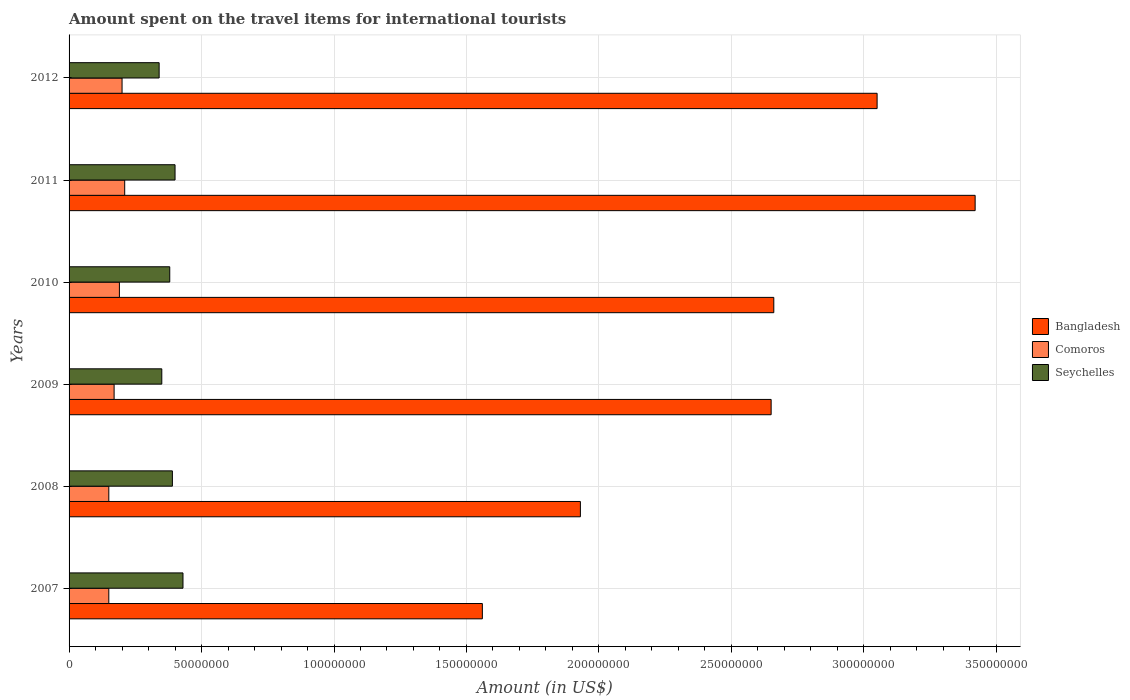How many groups of bars are there?
Make the answer very short. 6. Are the number of bars on each tick of the Y-axis equal?
Make the answer very short. Yes. What is the label of the 3rd group of bars from the top?
Your answer should be compact. 2010. What is the amount spent on the travel items for international tourists in Bangladesh in 2007?
Keep it short and to the point. 1.56e+08. Across all years, what is the maximum amount spent on the travel items for international tourists in Seychelles?
Provide a succinct answer. 4.30e+07. Across all years, what is the minimum amount spent on the travel items for international tourists in Comoros?
Make the answer very short. 1.50e+07. In which year was the amount spent on the travel items for international tourists in Comoros maximum?
Make the answer very short. 2011. What is the total amount spent on the travel items for international tourists in Comoros in the graph?
Make the answer very short. 1.07e+08. What is the difference between the amount spent on the travel items for international tourists in Bangladesh in 2008 and that in 2009?
Offer a very short reply. -7.20e+07. What is the difference between the amount spent on the travel items for international tourists in Bangladesh in 2009 and the amount spent on the travel items for international tourists in Seychelles in 2011?
Your answer should be compact. 2.25e+08. What is the average amount spent on the travel items for international tourists in Seychelles per year?
Ensure brevity in your answer.  3.82e+07. In the year 2012, what is the difference between the amount spent on the travel items for international tourists in Seychelles and amount spent on the travel items for international tourists in Bangladesh?
Your response must be concise. -2.71e+08. In how many years, is the amount spent on the travel items for international tourists in Bangladesh greater than 290000000 US$?
Provide a succinct answer. 2. Is the amount spent on the travel items for international tourists in Seychelles in 2010 less than that in 2012?
Your answer should be very brief. No. Is the difference between the amount spent on the travel items for international tourists in Seychelles in 2010 and 2011 greater than the difference between the amount spent on the travel items for international tourists in Bangladesh in 2010 and 2011?
Keep it short and to the point. Yes. What is the difference between the highest and the second highest amount spent on the travel items for international tourists in Comoros?
Make the answer very short. 1.00e+06. In how many years, is the amount spent on the travel items for international tourists in Comoros greater than the average amount spent on the travel items for international tourists in Comoros taken over all years?
Your response must be concise. 3. What does the 2nd bar from the top in 2012 represents?
Your answer should be compact. Comoros. What does the 1st bar from the bottom in 2009 represents?
Ensure brevity in your answer.  Bangladesh. Is it the case that in every year, the sum of the amount spent on the travel items for international tourists in Seychelles and amount spent on the travel items for international tourists in Comoros is greater than the amount spent on the travel items for international tourists in Bangladesh?
Offer a very short reply. No. How many bars are there?
Give a very brief answer. 18. Are all the bars in the graph horizontal?
Provide a succinct answer. Yes. What is the difference between two consecutive major ticks on the X-axis?
Your answer should be very brief. 5.00e+07. Where does the legend appear in the graph?
Your answer should be compact. Center right. How are the legend labels stacked?
Make the answer very short. Vertical. What is the title of the graph?
Your answer should be very brief. Amount spent on the travel items for international tourists. Does "San Marino" appear as one of the legend labels in the graph?
Your response must be concise. No. What is the Amount (in US$) of Bangladesh in 2007?
Ensure brevity in your answer.  1.56e+08. What is the Amount (in US$) in Comoros in 2007?
Offer a very short reply. 1.50e+07. What is the Amount (in US$) of Seychelles in 2007?
Your answer should be compact. 4.30e+07. What is the Amount (in US$) of Bangladesh in 2008?
Offer a terse response. 1.93e+08. What is the Amount (in US$) of Comoros in 2008?
Your answer should be very brief. 1.50e+07. What is the Amount (in US$) of Seychelles in 2008?
Keep it short and to the point. 3.90e+07. What is the Amount (in US$) in Bangladesh in 2009?
Your answer should be very brief. 2.65e+08. What is the Amount (in US$) in Comoros in 2009?
Offer a very short reply. 1.70e+07. What is the Amount (in US$) in Seychelles in 2009?
Keep it short and to the point. 3.50e+07. What is the Amount (in US$) in Bangladesh in 2010?
Keep it short and to the point. 2.66e+08. What is the Amount (in US$) of Comoros in 2010?
Provide a succinct answer. 1.90e+07. What is the Amount (in US$) in Seychelles in 2010?
Your answer should be compact. 3.80e+07. What is the Amount (in US$) in Bangladesh in 2011?
Your answer should be compact. 3.42e+08. What is the Amount (in US$) in Comoros in 2011?
Provide a short and direct response. 2.10e+07. What is the Amount (in US$) of Seychelles in 2011?
Your answer should be compact. 4.00e+07. What is the Amount (in US$) in Bangladesh in 2012?
Ensure brevity in your answer.  3.05e+08. What is the Amount (in US$) of Comoros in 2012?
Offer a very short reply. 2.00e+07. What is the Amount (in US$) of Seychelles in 2012?
Make the answer very short. 3.40e+07. Across all years, what is the maximum Amount (in US$) of Bangladesh?
Give a very brief answer. 3.42e+08. Across all years, what is the maximum Amount (in US$) in Comoros?
Provide a succinct answer. 2.10e+07. Across all years, what is the maximum Amount (in US$) of Seychelles?
Offer a terse response. 4.30e+07. Across all years, what is the minimum Amount (in US$) of Bangladesh?
Provide a succinct answer. 1.56e+08. Across all years, what is the minimum Amount (in US$) of Comoros?
Your response must be concise. 1.50e+07. Across all years, what is the minimum Amount (in US$) in Seychelles?
Ensure brevity in your answer.  3.40e+07. What is the total Amount (in US$) of Bangladesh in the graph?
Provide a succinct answer. 1.53e+09. What is the total Amount (in US$) in Comoros in the graph?
Keep it short and to the point. 1.07e+08. What is the total Amount (in US$) of Seychelles in the graph?
Give a very brief answer. 2.29e+08. What is the difference between the Amount (in US$) of Bangladesh in 2007 and that in 2008?
Your answer should be very brief. -3.70e+07. What is the difference between the Amount (in US$) of Comoros in 2007 and that in 2008?
Ensure brevity in your answer.  0. What is the difference between the Amount (in US$) of Seychelles in 2007 and that in 2008?
Ensure brevity in your answer.  4.00e+06. What is the difference between the Amount (in US$) in Bangladesh in 2007 and that in 2009?
Keep it short and to the point. -1.09e+08. What is the difference between the Amount (in US$) in Bangladesh in 2007 and that in 2010?
Your answer should be compact. -1.10e+08. What is the difference between the Amount (in US$) in Seychelles in 2007 and that in 2010?
Keep it short and to the point. 5.00e+06. What is the difference between the Amount (in US$) in Bangladesh in 2007 and that in 2011?
Provide a short and direct response. -1.86e+08. What is the difference between the Amount (in US$) of Comoros in 2007 and that in 2011?
Keep it short and to the point. -6.00e+06. What is the difference between the Amount (in US$) of Seychelles in 2007 and that in 2011?
Offer a very short reply. 3.00e+06. What is the difference between the Amount (in US$) in Bangladesh in 2007 and that in 2012?
Keep it short and to the point. -1.49e+08. What is the difference between the Amount (in US$) of Comoros in 2007 and that in 2012?
Provide a short and direct response. -5.00e+06. What is the difference between the Amount (in US$) of Seychelles in 2007 and that in 2012?
Keep it short and to the point. 9.00e+06. What is the difference between the Amount (in US$) in Bangladesh in 2008 and that in 2009?
Give a very brief answer. -7.20e+07. What is the difference between the Amount (in US$) of Comoros in 2008 and that in 2009?
Provide a succinct answer. -2.00e+06. What is the difference between the Amount (in US$) in Bangladesh in 2008 and that in 2010?
Offer a very short reply. -7.30e+07. What is the difference between the Amount (in US$) in Comoros in 2008 and that in 2010?
Keep it short and to the point. -4.00e+06. What is the difference between the Amount (in US$) in Seychelles in 2008 and that in 2010?
Provide a succinct answer. 1.00e+06. What is the difference between the Amount (in US$) of Bangladesh in 2008 and that in 2011?
Offer a very short reply. -1.49e+08. What is the difference between the Amount (in US$) in Comoros in 2008 and that in 2011?
Offer a very short reply. -6.00e+06. What is the difference between the Amount (in US$) in Seychelles in 2008 and that in 2011?
Make the answer very short. -1.00e+06. What is the difference between the Amount (in US$) of Bangladesh in 2008 and that in 2012?
Ensure brevity in your answer.  -1.12e+08. What is the difference between the Amount (in US$) of Comoros in 2008 and that in 2012?
Your response must be concise. -5.00e+06. What is the difference between the Amount (in US$) of Comoros in 2009 and that in 2010?
Give a very brief answer. -2.00e+06. What is the difference between the Amount (in US$) in Bangladesh in 2009 and that in 2011?
Give a very brief answer. -7.70e+07. What is the difference between the Amount (in US$) of Seychelles in 2009 and that in 2011?
Provide a succinct answer. -5.00e+06. What is the difference between the Amount (in US$) of Bangladesh in 2009 and that in 2012?
Make the answer very short. -4.00e+07. What is the difference between the Amount (in US$) in Bangladesh in 2010 and that in 2011?
Make the answer very short. -7.60e+07. What is the difference between the Amount (in US$) of Seychelles in 2010 and that in 2011?
Ensure brevity in your answer.  -2.00e+06. What is the difference between the Amount (in US$) in Bangladesh in 2010 and that in 2012?
Your answer should be compact. -3.90e+07. What is the difference between the Amount (in US$) of Comoros in 2010 and that in 2012?
Your answer should be very brief. -1.00e+06. What is the difference between the Amount (in US$) of Bangladesh in 2011 and that in 2012?
Provide a succinct answer. 3.70e+07. What is the difference between the Amount (in US$) in Comoros in 2011 and that in 2012?
Your answer should be very brief. 1.00e+06. What is the difference between the Amount (in US$) in Seychelles in 2011 and that in 2012?
Your response must be concise. 6.00e+06. What is the difference between the Amount (in US$) of Bangladesh in 2007 and the Amount (in US$) of Comoros in 2008?
Your response must be concise. 1.41e+08. What is the difference between the Amount (in US$) in Bangladesh in 2007 and the Amount (in US$) in Seychelles in 2008?
Ensure brevity in your answer.  1.17e+08. What is the difference between the Amount (in US$) of Comoros in 2007 and the Amount (in US$) of Seychelles in 2008?
Offer a terse response. -2.40e+07. What is the difference between the Amount (in US$) in Bangladesh in 2007 and the Amount (in US$) in Comoros in 2009?
Your response must be concise. 1.39e+08. What is the difference between the Amount (in US$) in Bangladesh in 2007 and the Amount (in US$) in Seychelles in 2009?
Your answer should be compact. 1.21e+08. What is the difference between the Amount (in US$) in Comoros in 2007 and the Amount (in US$) in Seychelles in 2009?
Your answer should be very brief. -2.00e+07. What is the difference between the Amount (in US$) in Bangladesh in 2007 and the Amount (in US$) in Comoros in 2010?
Offer a very short reply. 1.37e+08. What is the difference between the Amount (in US$) in Bangladesh in 2007 and the Amount (in US$) in Seychelles in 2010?
Your answer should be very brief. 1.18e+08. What is the difference between the Amount (in US$) in Comoros in 2007 and the Amount (in US$) in Seychelles in 2010?
Provide a succinct answer. -2.30e+07. What is the difference between the Amount (in US$) of Bangladesh in 2007 and the Amount (in US$) of Comoros in 2011?
Provide a short and direct response. 1.35e+08. What is the difference between the Amount (in US$) of Bangladesh in 2007 and the Amount (in US$) of Seychelles in 2011?
Offer a very short reply. 1.16e+08. What is the difference between the Amount (in US$) in Comoros in 2007 and the Amount (in US$) in Seychelles in 2011?
Give a very brief answer. -2.50e+07. What is the difference between the Amount (in US$) of Bangladesh in 2007 and the Amount (in US$) of Comoros in 2012?
Keep it short and to the point. 1.36e+08. What is the difference between the Amount (in US$) in Bangladesh in 2007 and the Amount (in US$) in Seychelles in 2012?
Your answer should be very brief. 1.22e+08. What is the difference between the Amount (in US$) in Comoros in 2007 and the Amount (in US$) in Seychelles in 2012?
Give a very brief answer. -1.90e+07. What is the difference between the Amount (in US$) of Bangladesh in 2008 and the Amount (in US$) of Comoros in 2009?
Your response must be concise. 1.76e+08. What is the difference between the Amount (in US$) of Bangladesh in 2008 and the Amount (in US$) of Seychelles in 2009?
Offer a very short reply. 1.58e+08. What is the difference between the Amount (in US$) in Comoros in 2008 and the Amount (in US$) in Seychelles in 2009?
Ensure brevity in your answer.  -2.00e+07. What is the difference between the Amount (in US$) in Bangladesh in 2008 and the Amount (in US$) in Comoros in 2010?
Your response must be concise. 1.74e+08. What is the difference between the Amount (in US$) in Bangladesh in 2008 and the Amount (in US$) in Seychelles in 2010?
Offer a terse response. 1.55e+08. What is the difference between the Amount (in US$) in Comoros in 2008 and the Amount (in US$) in Seychelles in 2010?
Your answer should be compact. -2.30e+07. What is the difference between the Amount (in US$) of Bangladesh in 2008 and the Amount (in US$) of Comoros in 2011?
Provide a short and direct response. 1.72e+08. What is the difference between the Amount (in US$) in Bangladesh in 2008 and the Amount (in US$) in Seychelles in 2011?
Your response must be concise. 1.53e+08. What is the difference between the Amount (in US$) of Comoros in 2008 and the Amount (in US$) of Seychelles in 2011?
Provide a succinct answer. -2.50e+07. What is the difference between the Amount (in US$) of Bangladesh in 2008 and the Amount (in US$) of Comoros in 2012?
Keep it short and to the point. 1.73e+08. What is the difference between the Amount (in US$) of Bangladesh in 2008 and the Amount (in US$) of Seychelles in 2012?
Your answer should be compact. 1.59e+08. What is the difference between the Amount (in US$) in Comoros in 2008 and the Amount (in US$) in Seychelles in 2012?
Offer a very short reply. -1.90e+07. What is the difference between the Amount (in US$) in Bangladesh in 2009 and the Amount (in US$) in Comoros in 2010?
Offer a very short reply. 2.46e+08. What is the difference between the Amount (in US$) in Bangladesh in 2009 and the Amount (in US$) in Seychelles in 2010?
Make the answer very short. 2.27e+08. What is the difference between the Amount (in US$) in Comoros in 2009 and the Amount (in US$) in Seychelles in 2010?
Ensure brevity in your answer.  -2.10e+07. What is the difference between the Amount (in US$) of Bangladesh in 2009 and the Amount (in US$) of Comoros in 2011?
Your answer should be very brief. 2.44e+08. What is the difference between the Amount (in US$) of Bangladesh in 2009 and the Amount (in US$) of Seychelles in 2011?
Your response must be concise. 2.25e+08. What is the difference between the Amount (in US$) of Comoros in 2009 and the Amount (in US$) of Seychelles in 2011?
Offer a terse response. -2.30e+07. What is the difference between the Amount (in US$) in Bangladesh in 2009 and the Amount (in US$) in Comoros in 2012?
Offer a terse response. 2.45e+08. What is the difference between the Amount (in US$) of Bangladesh in 2009 and the Amount (in US$) of Seychelles in 2012?
Offer a very short reply. 2.31e+08. What is the difference between the Amount (in US$) in Comoros in 2009 and the Amount (in US$) in Seychelles in 2012?
Provide a short and direct response. -1.70e+07. What is the difference between the Amount (in US$) of Bangladesh in 2010 and the Amount (in US$) of Comoros in 2011?
Your answer should be compact. 2.45e+08. What is the difference between the Amount (in US$) of Bangladesh in 2010 and the Amount (in US$) of Seychelles in 2011?
Your response must be concise. 2.26e+08. What is the difference between the Amount (in US$) of Comoros in 2010 and the Amount (in US$) of Seychelles in 2011?
Make the answer very short. -2.10e+07. What is the difference between the Amount (in US$) in Bangladesh in 2010 and the Amount (in US$) in Comoros in 2012?
Provide a succinct answer. 2.46e+08. What is the difference between the Amount (in US$) of Bangladesh in 2010 and the Amount (in US$) of Seychelles in 2012?
Your response must be concise. 2.32e+08. What is the difference between the Amount (in US$) in Comoros in 2010 and the Amount (in US$) in Seychelles in 2012?
Ensure brevity in your answer.  -1.50e+07. What is the difference between the Amount (in US$) of Bangladesh in 2011 and the Amount (in US$) of Comoros in 2012?
Keep it short and to the point. 3.22e+08. What is the difference between the Amount (in US$) in Bangladesh in 2011 and the Amount (in US$) in Seychelles in 2012?
Your answer should be compact. 3.08e+08. What is the difference between the Amount (in US$) of Comoros in 2011 and the Amount (in US$) of Seychelles in 2012?
Ensure brevity in your answer.  -1.30e+07. What is the average Amount (in US$) in Bangladesh per year?
Your answer should be compact. 2.54e+08. What is the average Amount (in US$) in Comoros per year?
Provide a succinct answer. 1.78e+07. What is the average Amount (in US$) of Seychelles per year?
Ensure brevity in your answer.  3.82e+07. In the year 2007, what is the difference between the Amount (in US$) of Bangladesh and Amount (in US$) of Comoros?
Your answer should be very brief. 1.41e+08. In the year 2007, what is the difference between the Amount (in US$) in Bangladesh and Amount (in US$) in Seychelles?
Make the answer very short. 1.13e+08. In the year 2007, what is the difference between the Amount (in US$) in Comoros and Amount (in US$) in Seychelles?
Make the answer very short. -2.80e+07. In the year 2008, what is the difference between the Amount (in US$) of Bangladesh and Amount (in US$) of Comoros?
Keep it short and to the point. 1.78e+08. In the year 2008, what is the difference between the Amount (in US$) in Bangladesh and Amount (in US$) in Seychelles?
Give a very brief answer. 1.54e+08. In the year 2008, what is the difference between the Amount (in US$) of Comoros and Amount (in US$) of Seychelles?
Your response must be concise. -2.40e+07. In the year 2009, what is the difference between the Amount (in US$) in Bangladesh and Amount (in US$) in Comoros?
Offer a terse response. 2.48e+08. In the year 2009, what is the difference between the Amount (in US$) in Bangladesh and Amount (in US$) in Seychelles?
Ensure brevity in your answer.  2.30e+08. In the year 2009, what is the difference between the Amount (in US$) of Comoros and Amount (in US$) of Seychelles?
Make the answer very short. -1.80e+07. In the year 2010, what is the difference between the Amount (in US$) of Bangladesh and Amount (in US$) of Comoros?
Keep it short and to the point. 2.47e+08. In the year 2010, what is the difference between the Amount (in US$) in Bangladesh and Amount (in US$) in Seychelles?
Offer a terse response. 2.28e+08. In the year 2010, what is the difference between the Amount (in US$) in Comoros and Amount (in US$) in Seychelles?
Offer a terse response. -1.90e+07. In the year 2011, what is the difference between the Amount (in US$) in Bangladesh and Amount (in US$) in Comoros?
Make the answer very short. 3.21e+08. In the year 2011, what is the difference between the Amount (in US$) in Bangladesh and Amount (in US$) in Seychelles?
Make the answer very short. 3.02e+08. In the year 2011, what is the difference between the Amount (in US$) in Comoros and Amount (in US$) in Seychelles?
Your answer should be very brief. -1.90e+07. In the year 2012, what is the difference between the Amount (in US$) of Bangladesh and Amount (in US$) of Comoros?
Ensure brevity in your answer.  2.85e+08. In the year 2012, what is the difference between the Amount (in US$) in Bangladesh and Amount (in US$) in Seychelles?
Provide a succinct answer. 2.71e+08. In the year 2012, what is the difference between the Amount (in US$) of Comoros and Amount (in US$) of Seychelles?
Ensure brevity in your answer.  -1.40e+07. What is the ratio of the Amount (in US$) of Bangladesh in 2007 to that in 2008?
Provide a succinct answer. 0.81. What is the ratio of the Amount (in US$) in Comoros in 2007 to that in 2008?
Give a very brief answer. 1. What is the ratio of the Amount (in US$) in Seychelles in 2007 to that in 2008?
Your answer should be very brief. 1.1. What is the ratio of the Amount (in US$) of Bangladesh in 2007 to that in 2009?
Give a very brief answer. 0.59. What is the ratio of the Amount (in US$) in Comoros in 2007 to that in 2009?
Provide a short and direct response. 0.88. What is the ratio of the Amount (in US$) in Seychelles in 2007 to that in 2009?
Provide a succinct answer. 1.23. What is the ratio of the Amount (in US$) in Bangladesh in 2007 to that in 2010?
Ensure brevity in your answer.  0.59. What is the ratio of the Amount (in US$) in Comoros in 2007 to that in 2010?
Ensure brevity in your answer.  0.79. What is the ratio of the Amount (in US$) in Seychelles in 2007 to that in 2010?
Your response must be concise. 1.13. What is the ratio of the Amount (in US$) in Bangladesh in 2007 to that in 2011?
Provide a short and direct response. 0.46. What is the ratio of the Amount (in US$) in Seychelles in 2007 to that in 2011?
Your answer should be compact. 1.07. What is the ratio of the Amount (in US$) in Bangladesh in 2007 to that in 2012?
Ensure brevity in your answer.  0.51. What is the ratio of the Amount (in US$) in Seychelles in 2007 to that in 2012?
Provide a short and direct response. 1.26. What is the ratio of the Amount (in US$) of Bangladesh in 2008 to that in 2009?
Offer a very short reply. 0.73. What is the ratio of the Amount (in US$) of Comoros in 2008 to that in 2009?
Provide a succinct answer. 0.88. What is the ratio of the Amount (in US$) of Seychelles in 2008 to that in 2009?
Your answer should be compact. 1.11. What is the ratio of the Amount (in US$) in Bangladesh in 2008 to that in 2010?
Provide a succinct answer. 0.73. What is the ratio of the Amount (in US$) in Comoros in 2008 to that in 2010?
Provide a succinct answer. 0.79. What is the ratio of the Amount (in US$) of Seychelles in 2008 to that in 2010?
Give a very brief answer. 1.03. What is the ratio of the Amount (in US$) of Bangladesh in 2008 to that in 2011?
Provide a succinct answer. 0.56. What is the ratio of the Amount (in US$) of Comoros in 2008 to that in 2011?
Ensure brevity in your answer.  0.71. What is the ratio of the Amount (in US$) of Seychelles in 2008 to that in 2011?
Give a very brief answer. 0.97. What is the ratio of the Amount (in US$) of Bangladesh in 2008 to that in 2012?
Make the answer very short. 0.63. What is the ratio of the Amount (in US$) in Seychelles in 2008 to that in 2012?
Keep it short and to the point. 1.15. What is the ratio of the Amount (in US$) of Comoros in 2009 to that in 2010?
Your answer should be compact. 0.89. What is the ratio of the Amount (in US$) in Seychelles in 2009 to that in 2010?
Provide a succinct answer. 0.92. What is the ratio of the Amount (in US$) of Bangladesh in 2009 to that in 2011?
Offer a very short reply. 0.77. What is the ratio of the Amount (in US$) in Comoros in 2009 to that in 2011?
Keep it short and to the point. 0.81. What is the ratio of the Amount (in US$) in Seychelles in 2009 to that in 2011?
Provide a short and direct response. 0.88. What is the ratio of the Amount (in US$) of Bangladesh in 2009 to that in 2012?
Keep it short and to the point. 0.87. What is the ratio of the Amount (in US$) in Comoros in 2009 to that in 2012?
Give a very brief answer. 0.85. What is the ratio of the Amount (in US$) of Seychelles in 2009 to that in 2012?
Your answer should be compact. 1.03. What is the ratio of the Amount (in US$) in Bangladesh in 2010 to that in 2011?
Provide a succinct answer. 0.78. What is the ratio of the Amount (in US$) of Comoros in 2010 to that in 2011?
Offer a very short reply. 0.9. What is the ratio of the Amount (in US$) of Seychelles in 2010 to that in 2011?
Provide a short and direct response. 0.95. What is the ratio of the Amount (in US$) of Bangladesh in 2010 to that in 2012?
Your answer should be very brief. 0.87. What is the ratio of the Amount (in US$) of Comoros in 2010 to that in 2012?
Provide a short and direct response. 0.95. What is the ratio of the Amount (in US$) in Seychelles in 2010 to that in 2012?
Your response must be concise. 1.12. What is the ratio of the Amount (in US$) of Bangladesh in 2011 to that in 2012?
Offer a very short reply. 1.12. What is the ratio of the Amount (in US$) in Comoros in 2011 to that in 2012?
Offer a very short reply. 1.05. What is the ratio of the Amount (in US$) of Seychelles in 2011 to that in 2012?
Provide a succinct answer. 1.18. What is the difference between the highest and the second highest Amount (in US$) of Bangladesh?
Keep it short and to the point. 3.70e+07. What is the difference between the highest and the second highest Amount (in US$) in Comoros?
Your answer should be compact. 1.00e+06. What is the difference between the highest and the second highest Amount (in US$) in Seychelles?
Your answer should be compact. 3.00e+06. What is the difference between the highest and the lowest Amount (in US$) of Bangladesh?
Make the answer very short. 1.86e+08. What is the difference between the highest and the lowest Amount (in US$) of Seychelles?
Provide a short and direct response. 9.00e+06. 